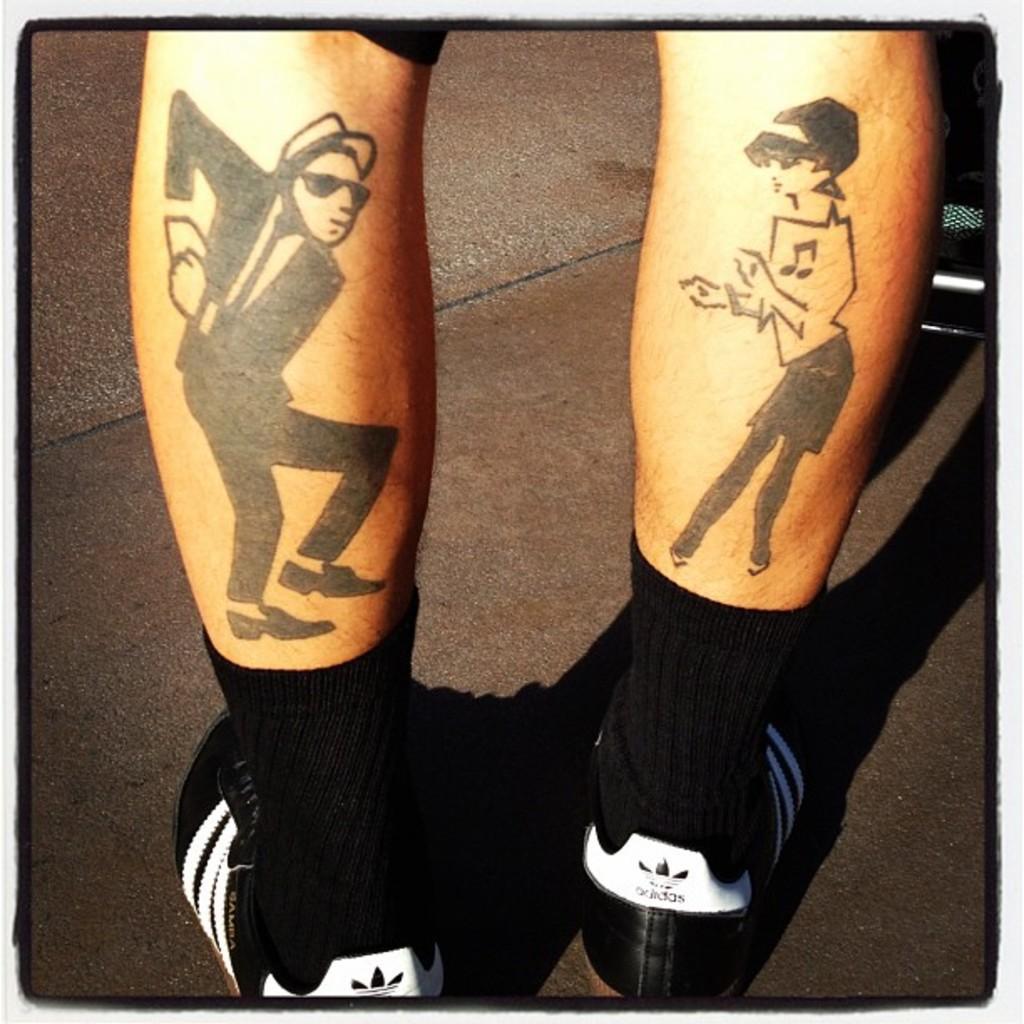Can you describe this image briefly? In this picture there are two legs in the image, on which there is painting. 